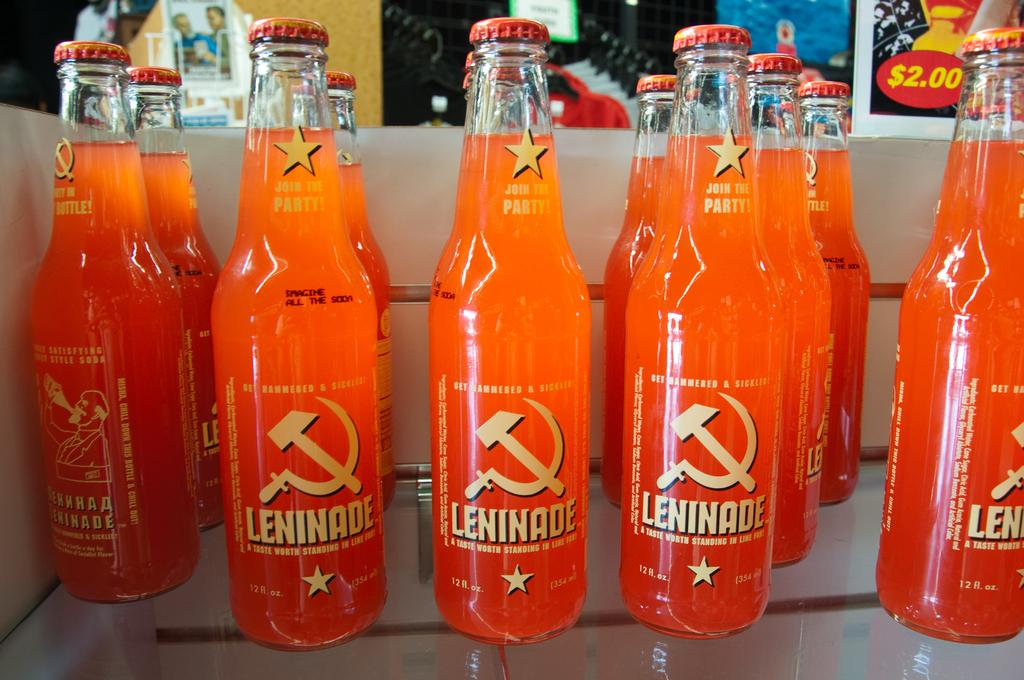<image>
Provide a brief description of the given image. Several lines of clear glass bottles with orange Leninade, with a hammer and sickle logo on the label and yellow text. 